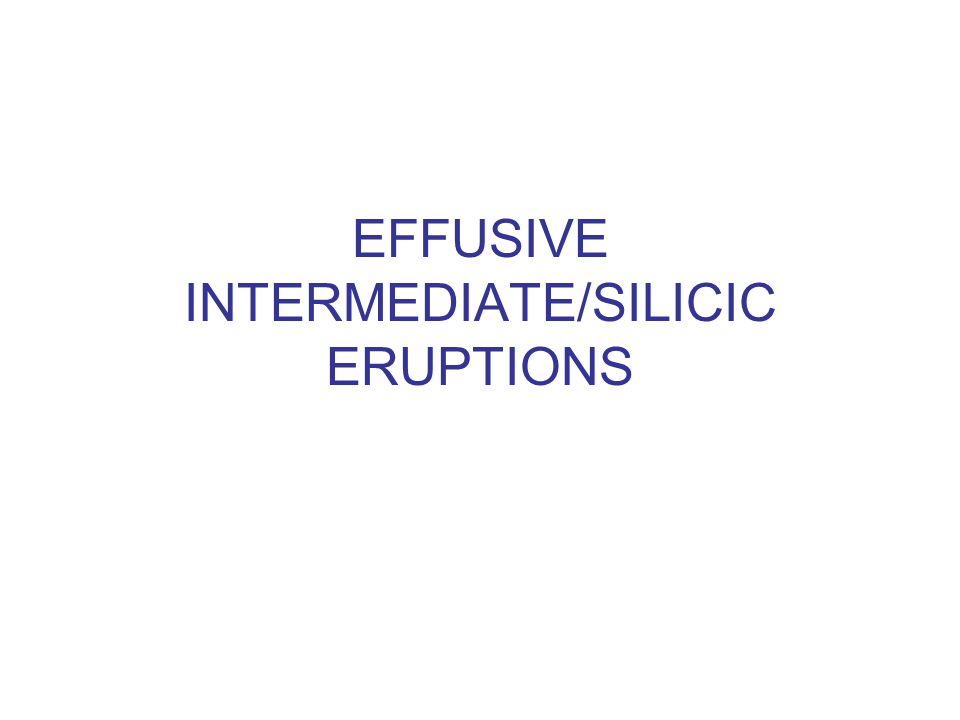How are these volcanic classifications used in practical scenarios? Volcanic classifications like effusive, intermediate, and silicic are integral in volcanic hazard planning and response. By understanding the type of eruption likely to occur, scientists and emergency responders can better predict and mitigate its impacts on nearby communities. For example, effusive eruptions might require road closures due to lava flows, while explosive eruptions could necessitate broader evacuation orders and air traffic rerouting due to ash clouds. 